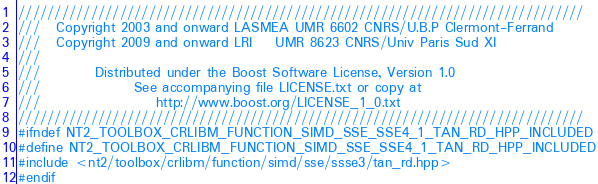<code> <loc_0><loc_0><loc_500><loc_500><_C++_>//////////////////////////////////////////////////////////////////////////////
///   Copyright 2003 and onward LASMEA UMR 6602 CNRS/U.B.P Clermont-Ferrand
///   Copyright 2009 and onward LRI    UMR 8623 CNRS/Univ Paris Sud XI
///
///          Distributed under the Boost Software License, Version 1.0
///                 See accompanying file LICENSE.txt or copy at
///                     http://www.boost.org/LICENSE_1_0.txt
//////////////////////////////////////////////////////////////////////////////
#ifndef NT2_TOOLBOX_CRLIBM_FUNCTION_SIMD_SSE_SSE4_1_TAN_RD_HPP_INCLUDED
#define NT2_TOOLBOX_CRLIBM_FUNCTION_SIMD_SSE_SSE4_1_TAN_RD_HPP_INCLUDED
#include <nt2/toolbox/crlibm/function/simd/sse/ssse3/tan_rd.hpp>
#endif
</code> 